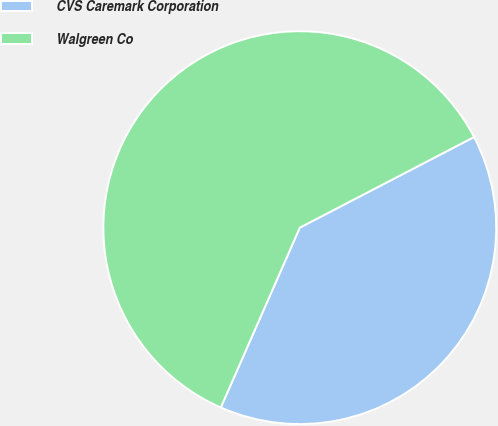Convert chart to OTSL. <chart><loc_0><loc_0><loc_500><loc_500><pie_chart><fcel>CVS Caremark Corporation<fcel>Walgreen Co<nl><fcel>39.22%<fcel>60.78%<nl></chart> 